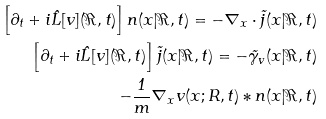Convert formula to latex. <formula><loc_0><loc_0><loc_500><loc_500>\left [ \partial _ { t } + i \hat { L } [ v ] ( \Re , t ) \right ] n ( { x } | \Re , t ) = - \nabla _ { x } \cdot \vec { j } ( { x } | \Re , t ) \\ \left [ \partial _ { t } + i \hat { L } [ v ] ( \Re , t ) \right ] \vec { j } ( { x } | \Re , t ) = - \vec { \gamma } _ { v } ( { x } | \Re , t ) \\ - \frac { 1 } { m } \nabla _ { x } v ( { x ; R } , t ) * n ( { x } | \Re , t )</formula> 